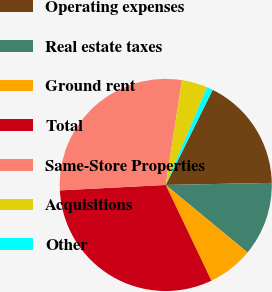Convert chart to OTSL. <chart><loc_0><loc_0><loc_500><loc_500><pie_chart><fcel>Operating expenses<fcel>Real estate taxes<fcel>Ground rent<fcel>Total<fcel>Same-Store Properties<fcel>Acquisitions<fcel>Other<nl><fcel>17.39%<fcel>11.29%<fcel>6.94%<fcel>31.27%<fcel>28.26%<fcel>3.93%<fcel>0.92%<nl></chart> 